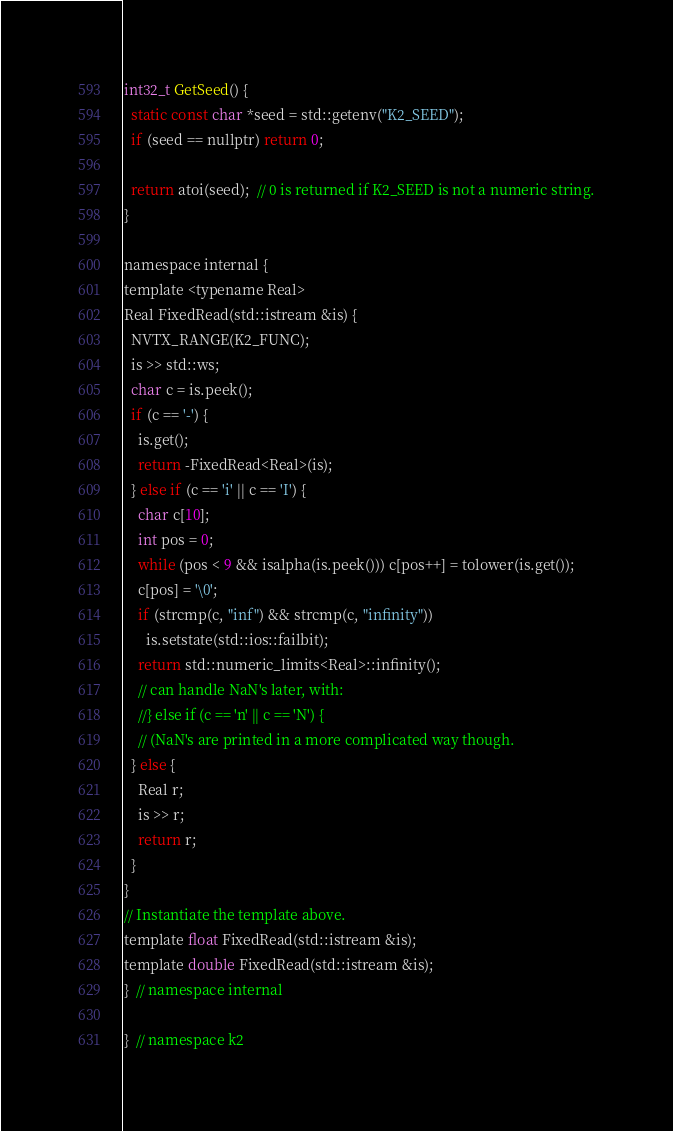<code> <loc_0><loc_0><loc_500><loc_500><_Cuda_>int32_t GetSeed() {
  static const char *seed = std::getenv("K2_SEED");
  if (seed == nullptr) return 0;

  return atoi(seed);  // 0 is returned if K2_SEED is not a numeric string.
}

namespace internal {
template <typename Real>
Real FixedRead(std::istream &is) {
  NVTX_RANGE(K2_FUNC);
  is >> std::ws;
  char c = is.peek();
  if (c == '-') {
    is.get();
    return -FixedRead<Real>(is);
  } else if (c == 'i' || c == 'I') {
    char c[10];
    int pos = 0;
    while (pos < 9 && isalpha(is.peek())) c[pos++] = tolower(is.get());
    c[pos] = '\0';
    if (strcmp(c, "inf") && strcmp(c, "infinity"))
      is.setstate(std::ios::failbit);
    return std::numeric_limits<Real>::infinity();
    // can handle NaN's later, with:
    //} else if (c == 'n' || c == 'N') {
    // (NaN's are printed in a more complicated way though.
  } else {
    Real r;
    is >> r;
    return r;
  }
}
// Instantiate the template above.
template float FixedRead(std::istream &is);
template double FixedRead(std::istream &is);
}  // namespace internal

}  // namespace k2
</code> 